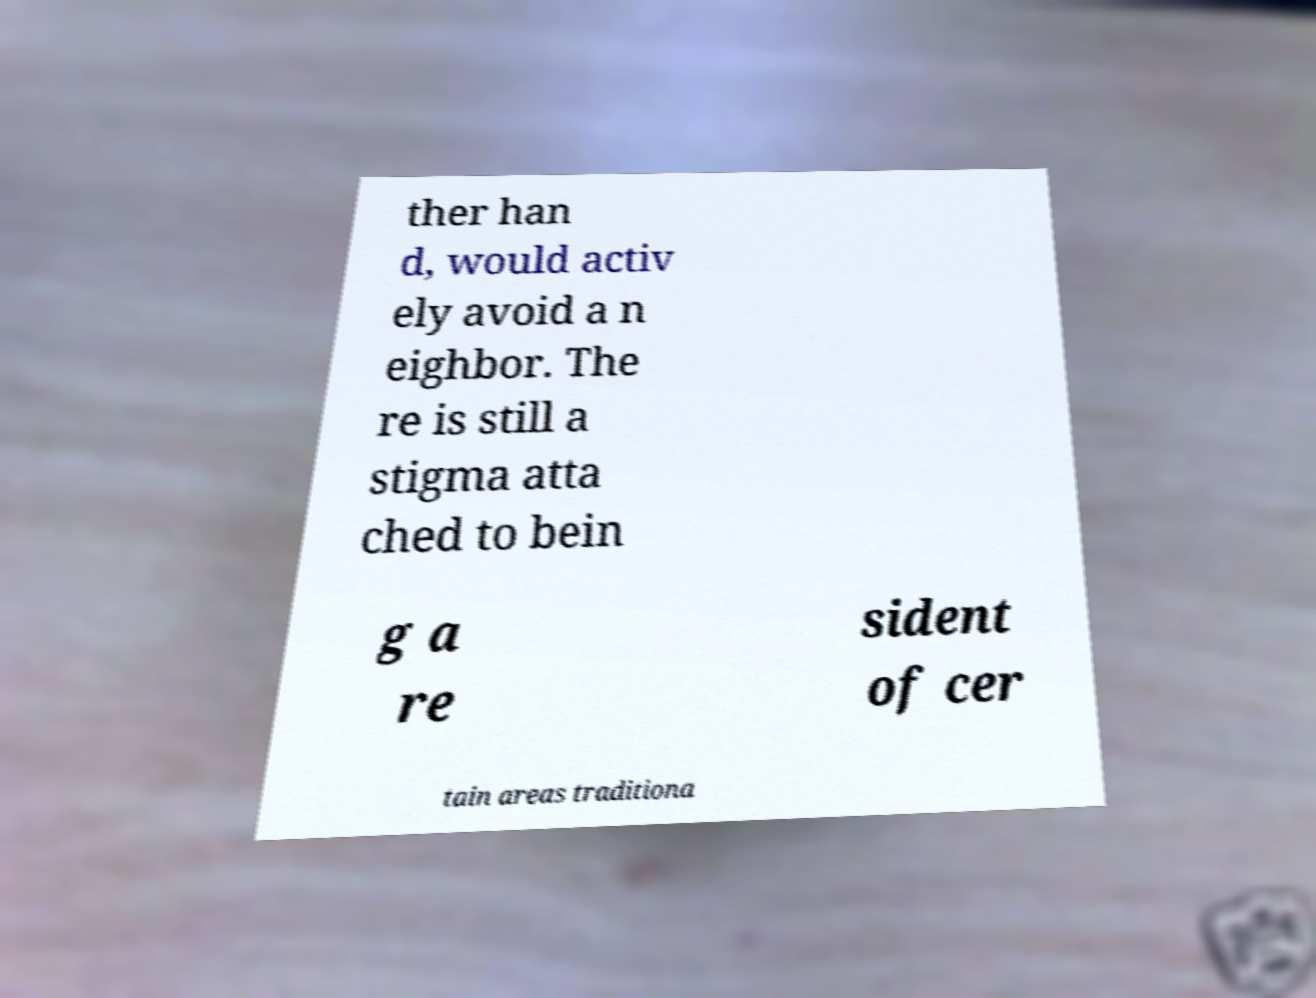Please identify and transcribe the text found in this image. ther han d, would activ ely avoid a n eighbor. The re is still a stigma atta ched to bein g a re sident of cer tain areas traditiona 